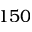Convert formula to latex. <formula><loc_0><loc_0><loc_500><loc_500>1 5 0</formula> 